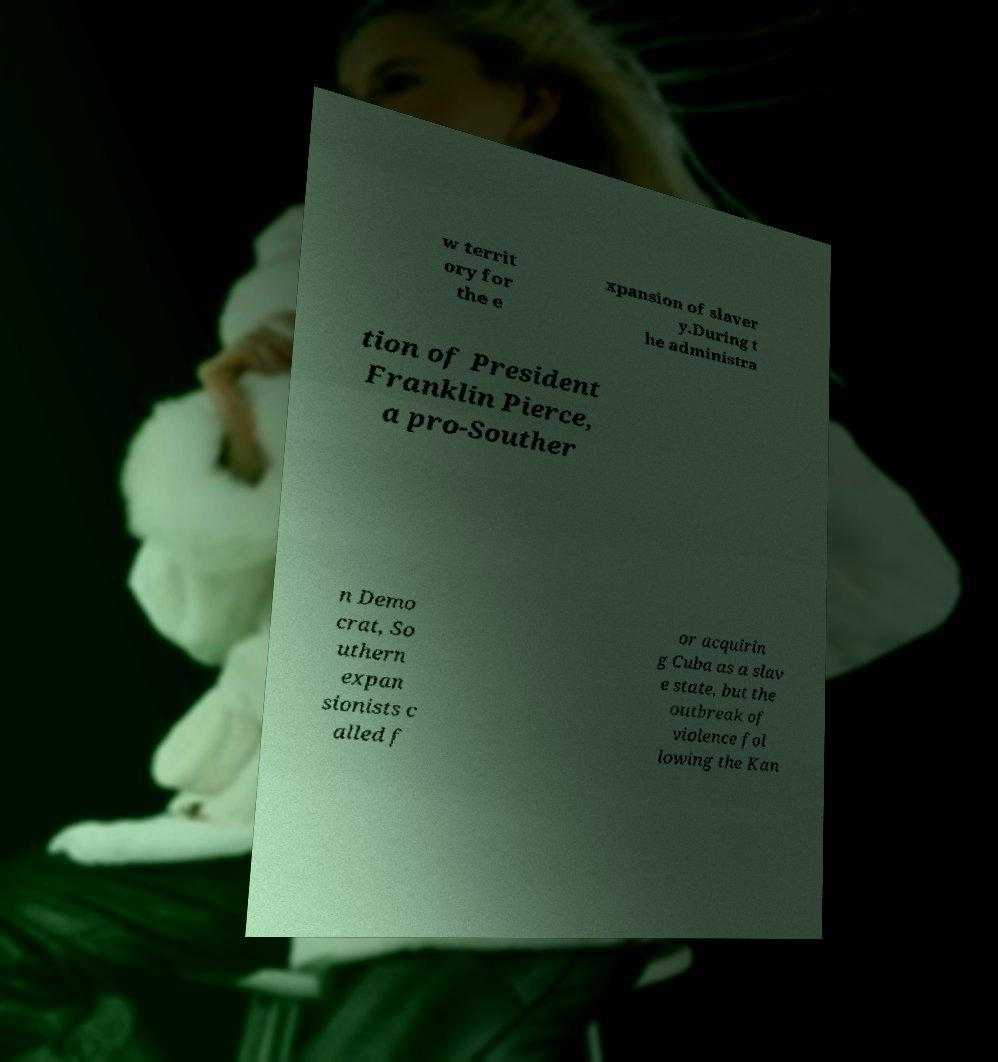There's text embedded in this image that I need extracted. Can you transcribe it verbatim? w territ ory for the e xpansion of slaver y.During t he administra tion of President Franklin Pierce, a pro-Souther n Demo crat, So uthern expan sionists c alled f or acquirin g Cuba as a slav e state, but the outbreak of violence fol lowing the Kan 